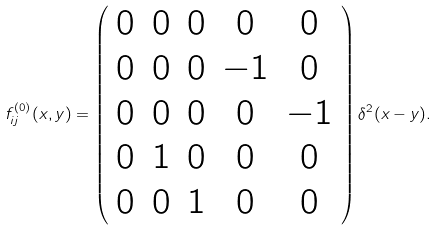<formula> <loc_0><loc_0><loc_500><loc_500>f ^ { ( 0 ) } _ { i j } ( x , y ) = \left ( \begin{array} { c c c c c } 0 & 0 & 0 & 0 & 0 \\ 0 & 0 & 0 & - 1 & 0 \\ 0 & 0 & 0 & 0 & - 1 \\ 0 & 1 & 0 & 0 & 0 \\ 0 & 0 & 1 & 0 & 0 \\ \end{array} \right ) \delta ^ { 2 } ( x - y ) .</formula> 